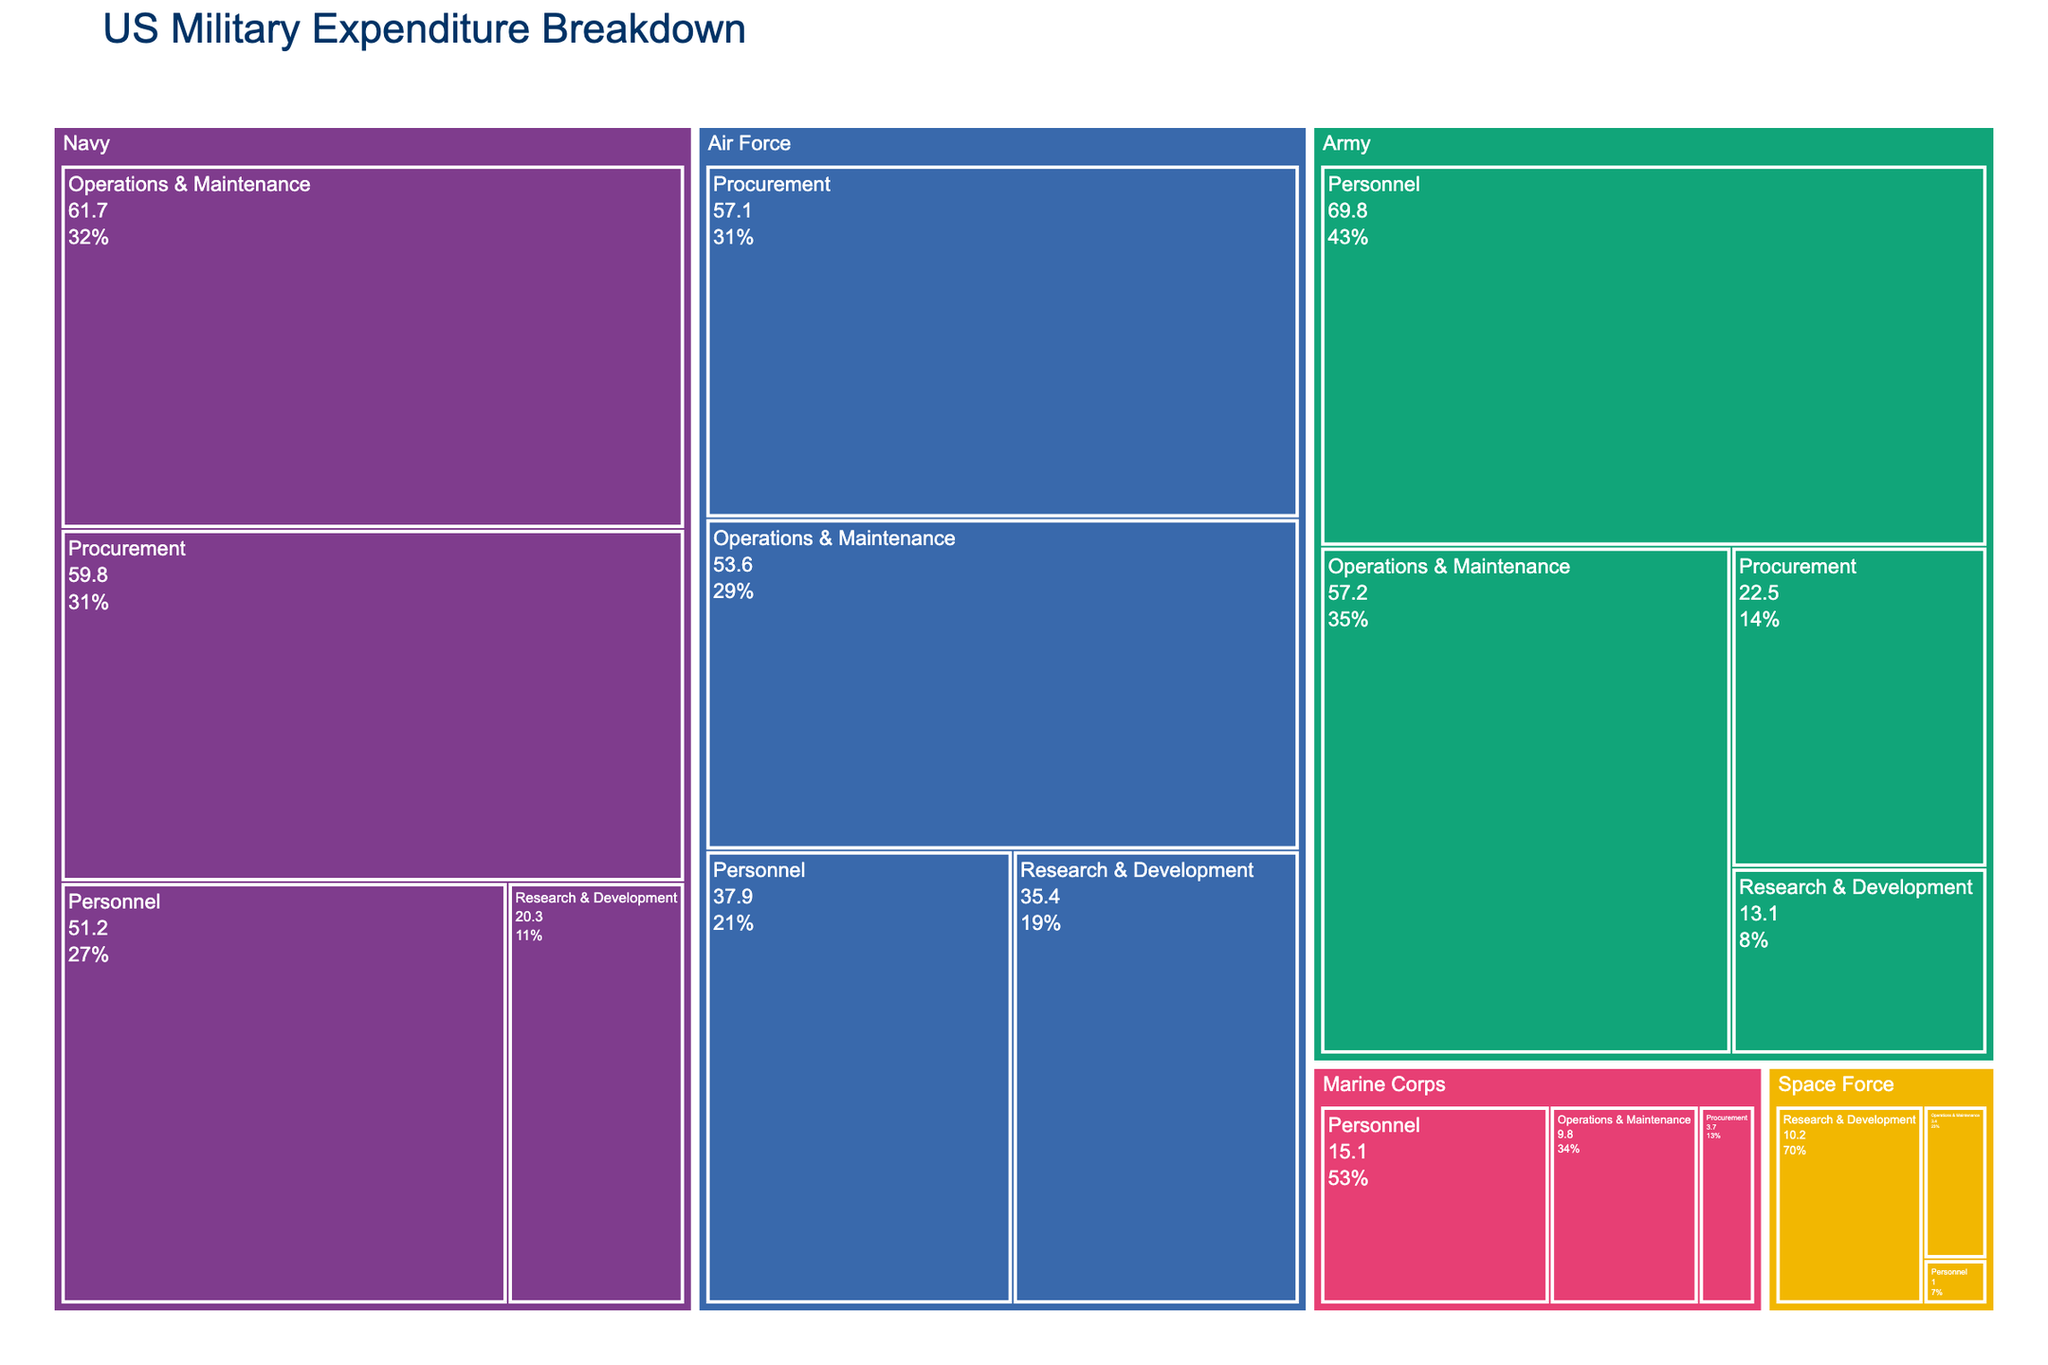What is the title of the figure? The title is usually located at the top of the figure and describes what the figure is about. It helps provide context and allows the viewer to understand the subject matter of the figure at a glance.
Answer: US Military Expenditure Breakdown How many expenditure categories are there for the Army? In a treemap, categories are typically organized into rectangles with labels indicating each category. The Army's categories are visible from the branch's labeled sections.
Answer: 4 Which branch has the highest total expenditure in the Personnel category? To determine this, we check the Personnel category for each branch and compare the values given in each section. The branch with the highest number will be identified.
Answer: Army What is the combined expenditure for Research & Development across all branches? To find this, sum up the expenditure values for Research & Development from all branches: Army, Navy, Air Force, and Space Force. (13.1 + 20.3 + 35.4 + 10.2)
Answer: 79.0 Which branch has the smallest total expenditure, and what is the amount? The smallest total expenditure can be identified by summing the expenditures for all the categories within each branch and comparing these sums. The branch with the smallest sum is the answer.
Answer: Space Force, 14.6 Is the expenditure on Operations & Maintenance higher for the Navy or the Air Force? To answer, compare the expenditure values for Operations & Maintenance listed under the Navy and the Air Force categories.
Answer: Navy What percentage of the Marine Corps' total expenditure is dedicated to Personnel? Calculate the total expenditure of the Marine Corps first (Personnel + Operations & Maintenance + Procurement). Then, divide the Personnel expenditure by this total and convert it to a percentage. (15.1 / (15.1 + 9.8 + 3.7) * 100)
Answer: 52.08% Which branch spends more on Procurement, the Navy or the Air Force, and by how much? Compare the Procurement expenditures of the Navy and the Air Force. Subtract the smaller value from the larger one to find the difference. (59.8 - 57.1)
Answer: Navy by 2.7 What is the average expenditure per category for the Space Force? Sum up all the expenditures for the Space Force and divide by the number of categories. ((1.0 + 3.4 + 10.2) / 3)
Answer: 4.87 Among all branches, which category has the highest single expenditure item, and what is the value? Identify the highest expenditure value among all categories across all branches. The highest value is the answer, along with its corresponding category.
Answer: Navy, Procurement, 59.8 